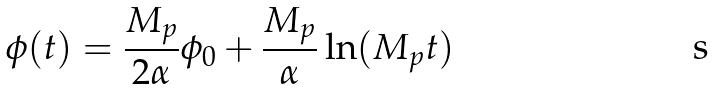<formula> <loc_0><loc_0><loc_500><loc_500>\phi ( t ) = \frac { M _ { p } } { 2 \alpha } \phi _ { 0 } + \frac { M _ { p } } { \alpha } \ln ( M _ { p } t )</formula> 